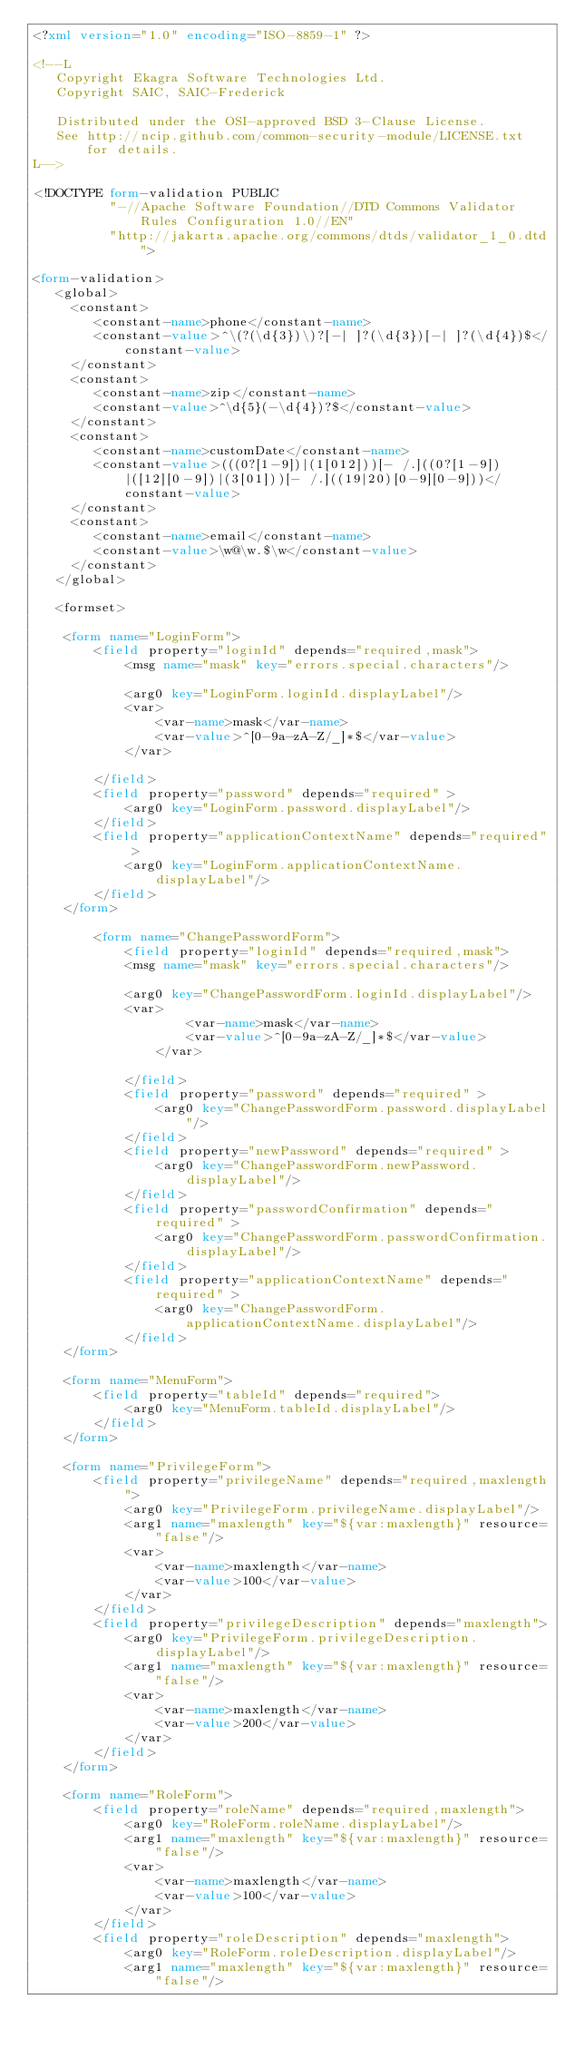Convert code to text. <code><loc_0><loc_0><loc_500><loc_500><_XML_><?xml version="1.0" encoding="ISO-8859-1" ?>

<!--L
   Copyright Ekagra Software Technologies Ltd.
   Copyright SAIC, SAIC-Frederick

   Distributed under the OSI-approved BSD 3-Clause License.
   See http://ncip.github.com/common-security-module/LICENSE.txt for details.
L-->

<!DOCTYPE form-validation PUBLIC
          "-//Apache Software Foundation//DTD Commons Validator Rules Configuration 1.0//EN"
          "http://jakarta.apache.org/commons/dtds/validator_1_0.dtd">

<form-validation>
   <global>
     <constant>
        <constant-name>phone</constant-name>
        <constant-value>^\(?(\d{3})\)?[-| ]?(\d{3})[-| ]?(\d{4})$</constant-value>
     </constant>
     <constant>
        <constant-name>zip</constant-name>
        <constant-value>^\d{5}(-\d{4})?$</constant-value>
     </constant>
     <constant>
        <constant-name>customDate</constant-name>
        <constant-value>(((0?[1-9])|(1[012]))[- /.]((0?[1-9])|([12][0-9])|(3[01]))[- /.]((19|20)[0-9][0-9]))</constant-value>
     </constant>
     <constant>
        <constant-name>email</constant-name>
        <constant-value>\w@\w.$\w</constant-value>
     </constant>
   </global>
   
   <formset>

  	<form name="LoginForm">
 		<field property="loginId" depends="required,mask">
			<msg name="mask" key="errors.special.characters"/>  			
			<arg0 key="LoginForm.loginId.displayLabel"/>
			<var>
  				<var-name>mask</var-name>
  				<var-value>^[0-9a-zA-Z/_]*$</var-value>
  			</var>
			
  		</field>
  		<field property="password" depends="required" >
  			<arg0 key="LoginForm.password.displayLabel"/>
  		</field>
  		<field property="applicationContextName" depends="required" >
  			<arg0 key="LoginForm.applicationContextName.displayLabel"/>
  		</field>
	</form>
   
     	<form name="ChangePasswordForm">
    		<field property="loginId" depends="required,mask">
   			<msg name="mask" key="errors.special.characters"/>  			
   			<arg0 key="ChangePasswordForm.loginId.displayLabel"/>
   			<var>
     				<var-name>mask</var-name>
     				<var-value>^[0-9a-zA-Z/_]*$</var-value>
     			</var>
   			
     		</field>
     		<field property="password" depends="required" >
     			<arg0 key="ChangePasswordForm.password.displayLabel"/>
     		</field>
    		<field property="newPassword" depends="required" >
     			<arg0 key="ChangePasswordForm.newPassword.displayLabel"/>
     		</field>
    		<field property="passwordConfirmation" depends="required" >
     			<arg0 key="ChangePasswordForm.passwordConfirmation.displayLabel"/>
     		</field>     		
     		<field property="applicationContextName" depends="required" >
     			<arg0 key="ChangePasswordForm.applicationContextName.displayLabel"/>
     		</field>
	</form>
   
  	<form name="MenuForm">
 		<field property="tableId" depends="required">
  			<arg0 key="MenuForm.tableId.displayLabel"/>
  		</field>
	</form>
   
    <form name="PrivilegeForm">
		<field property="privilegeName" depends="required,maxlength">
  			<arg0 key="PrivilegeForm.privilegeName.displayLabel"/>
  			<arg1 name="maxlength" key="${var:maxlength}" resource="false"/>
  			<var>
  				<var-name>maxlength</var-name>
  				<var-value>100</var-value>
  			</var>
  		</field>
		<field property="privilegeDescription" depends="maxlength">
  			<arg0 key="PrivilegeForm.privilegeDescription.displayLabel"/>
  			<arg1 name="maxlength" key="${var:maxlength}" resource="false"/>
  			<var>
  				<var-name>maxlength</var-name>
  				<var-value>200</var-value>
  			</var>
  		</field>
    </form>

    <form name="RoleForm">
		<field property="roleName" depends="required,maxlength">
  			<arg0 key="RoleForm.roleName.displayLabel"/>
  			<arg1 name="maxlength" key="${var:maxlength}" resource="false"/>
  			<var>
  				<var-name>maxlength</var-name>
  				<var-value>100</var-value>
  			</var>
  		</field>
		<field property="roleDescription" depends="maxlength">
  			<arg0 key="RoleForm.roleDescription.displayLabel"/>
  			<arg1 name="maxlength" key="${var:maxlength}" resource="false"/></code> 